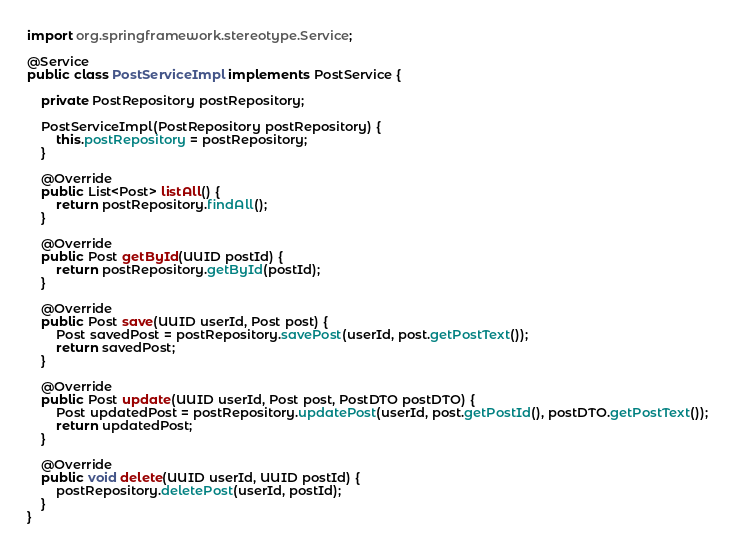Convert code to text. <code><loc_0><loc_0><loc_500><loc_500><_Java_>import org.springframework.stereotype.Service;

@Service
public class PostServiceImpl implements PostService {

    private PostRepository postRepository;

    PostServiceImpl(PostRepository postRepository) {
        this.postRepository = postRepository;
    }

    @Override
    public List<Post> listAll() {
        return postRepository.findAll();
    }

    @Override
    public Post getById(UUID postId) {
        return postRepository.getById(postId);
    }

    @Override
    public Post save(UUID userId, Post post) {
        Post savedPost = postRepository.savePost(userId, post.getPostText());
        return savedPost;
    }

    @Override
    public Post update(UUID userId, Post post, PostDTO postDTO) {
        Post updatedPost = postRepository.updatePost(userId, post.getPostId(), postDTO.getPostText());
        return updatedPost;
    }

    @Override
    public void delete(UUID userId, UUID postId) {
        postRepository.deletePost(userId, postId);
    }
}
</code> 